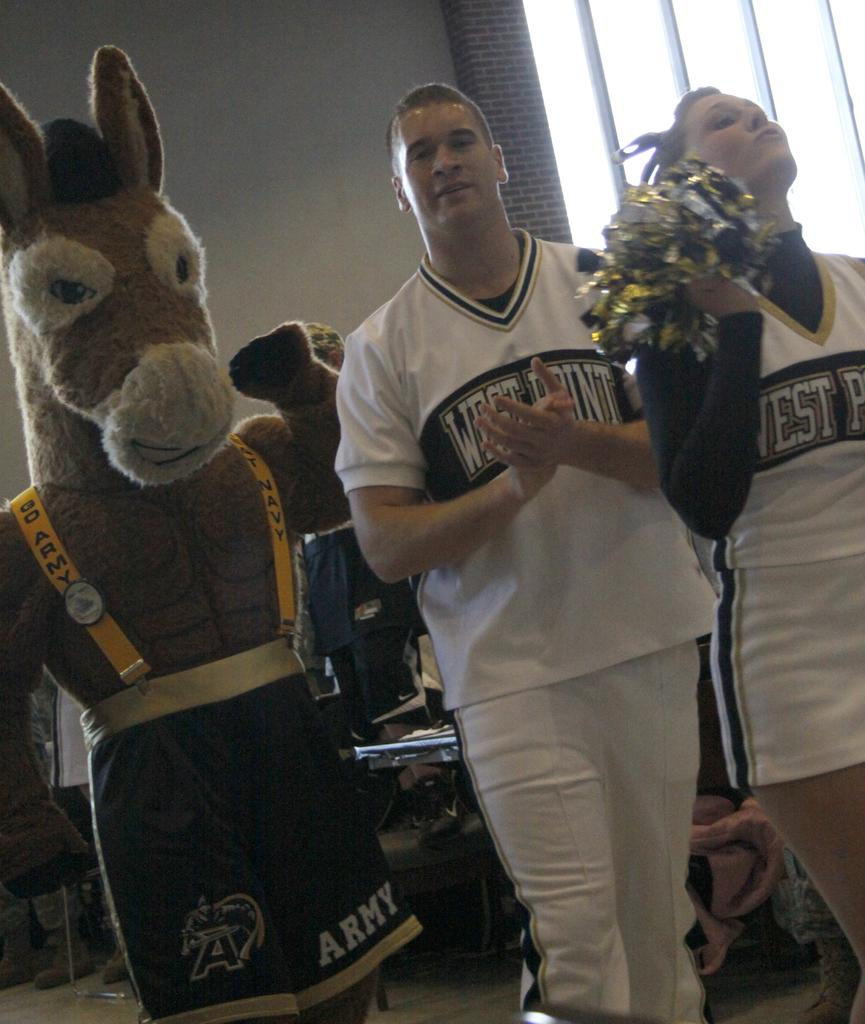<image>
Describe the image concisely. A donkey mascot has shorts on that say Army on one leg. 